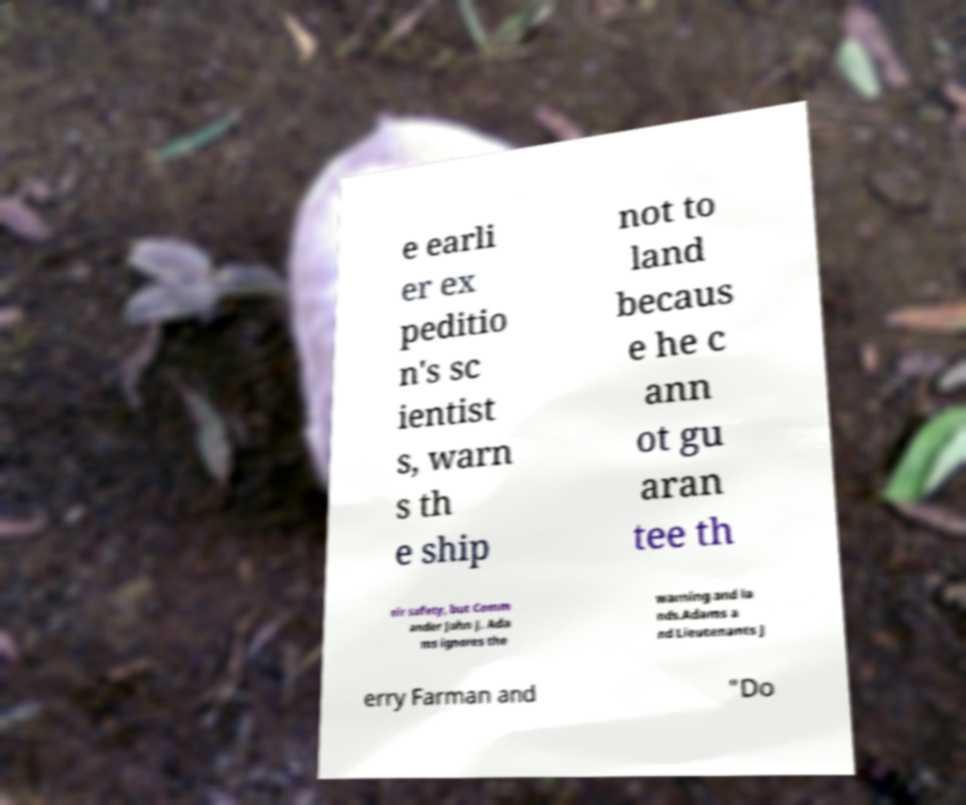Please read and relay the text visible in this image. What does it say? e earli er ex peditio n's sc ientist s, warn s th e ship not to land becaus e he c ann ot gu aran tee th eir safety, but Comm ander John J. Ada ms ignores the warning and la nds.Adams a nd Lieutenants J erry Farman and "Do 